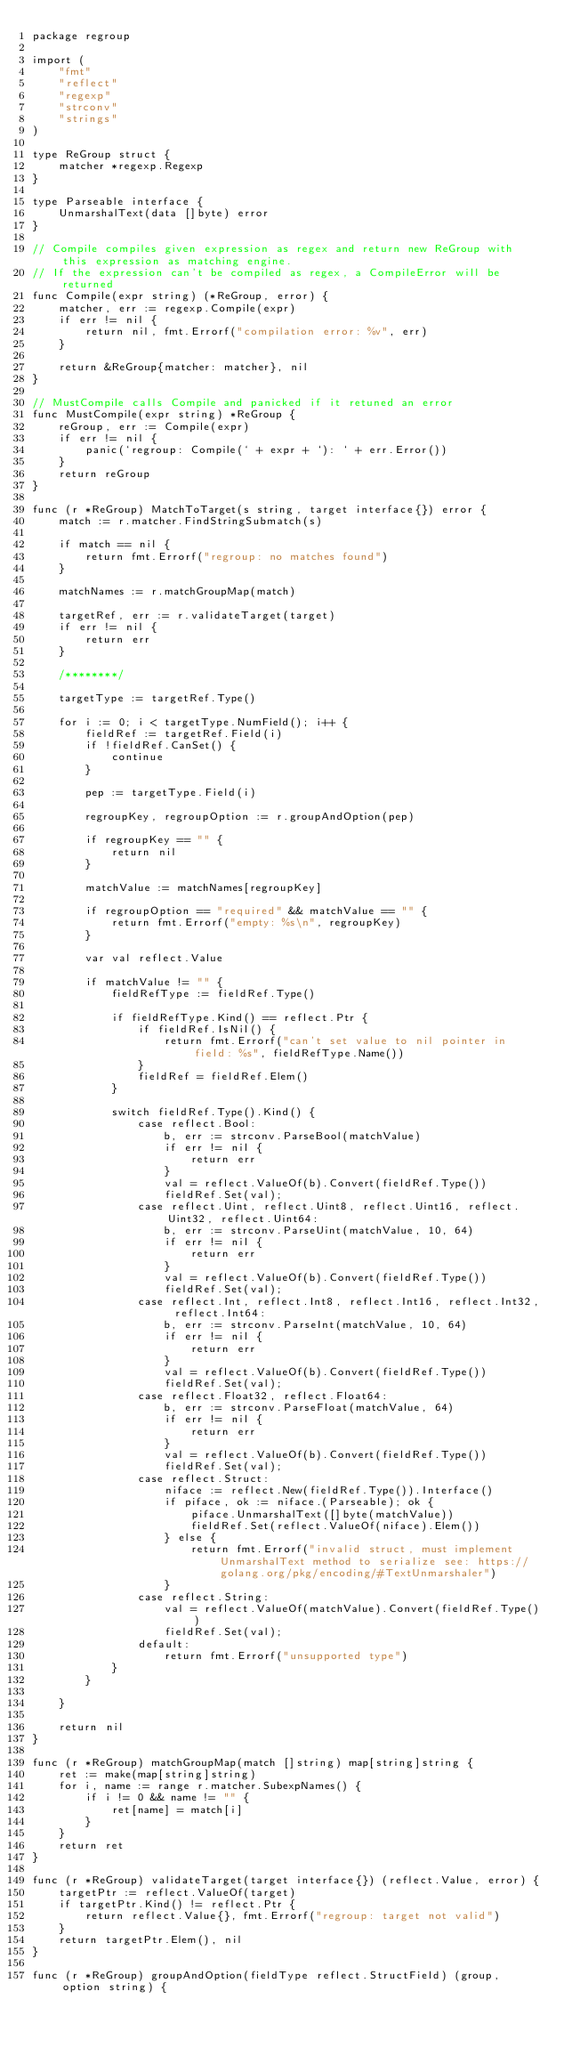<code> <loc_0><loc_0><loc_500><loc_500><_Go_>package regroup

import (
	"fmt"
	"reflect"
	"regexp"
	"strconv"
	"strings"
)

type ReGroup struct {
	matcher *regexp.Regexp
}

type Parseable interface {
	UnmarshalText(data []byte) error 
}

// Compile compiles given expression as regex and return new ReGroup with this expression as matching engine.
// If the expression can't be compiled as regex, a CompileError will be returned
func Compile(expr string) (*ReGroup, error) {
	matcher, err := regexp.Compile(expr)
	if err != nil {
		return nil, fmt.Errorf("compilation error: %v", err)
	}

	return &ReGroup{matcher: matcher}, nil
}

// MustCompile calls Compile and panicked if it retuned an error
func MustCompile(expr string) *ReGroup {
	reGroup, err := Compile(expr)
	if err != nil {
		panic(`regroup: Compile(` + expr + `): ` + err.Error())
	}
	return reGroup
}

func (r *ReGroup) MatchToTarget(s string, target interface{}) error {
	match := r.matcher.FindStringSubmatch(s)
	
	if match == nil {
		return fmt.Errorf("regroup: no matches found")
	}

	matchNames := r.matchGroupMap(match)

	targetRef, err := r.validateTarget(target)
	if err != nil {
		return err
	}

	/********/

	targetType := targetRef.Type()

	for i := 0; i < targetType.NumField(); i++ {
		fieldRef := targetRef.Field(i)
		if !fieldRef.CanSet() {
			continue
		}

		pep := targetType.Field(i)
		
		regroupKey, regroupOption := r.groupAndOption(pep)
		
		if regroupKey == "" {
			return nil
		}

		matchValue := matchNames[regroupKey]
		
		if regroupOption == "required" && matchValue == "" {
			return fmt.Errorf("empty: %s\n", regroupKey)
		}

		var val reflect.Value

		if matchValue != "" {
			fieldRefType := fieldRef.Type()

			if fieldRefType.Kind() == reflect.Ptr {
				if fieldRef.IsNil() {
					return fmt.Errorf("can't set value to nil pointer in field: %s", fieldRefType.Name())
				}
				fieldRef = fieldRef.Elem()
			}
			
			switch fieldRef.Type().Kind() {
				case reflect.Bool:
					b, err := strconv.ParseBool(matchValue)
					if err != nil {
						return err
					}
					val = reflect.ValueOf(b).Convert(fieldRef.Type())
					fieldRef.Set(val);
				case reflect.Uint, reflect.Uint8, reflect.Uint16, reflect.Uint32, reflect.Uint64:
					b, err := strconv.ParseUint(matchValue, 10, 64)
					if err != nil {
						return err
					}
					val = reflect.ValueOf(b).Convert(fieldRef.Type())
					fieldRef.Set(val);
				case reflect.Int, reflect.Int8, reflect.Int16, reflect.Int32, reflect.Int64:
					b, err := strconv.ParseInt(matchValue, 10, 64)
					if err != nil {
						return err
					}
					val = reflect.ValueOf(b).Convert(fieldRef.Type())
					fieldRef.Set(val);
				case reflect.Float32, reflect.Float64:
					b, err := strconv.ParseFloat(matchValue, 64)
					if err != nil {
						return err
					}
					val = reflect.ValueOf(b).Convert(fieldRef.Type())
					fieldRef.Set(val);
				case reflect.Struct:
					niface := reflect.New(fieldRef.Type()).Interface()
					if piface, ok := niface.(Parseable); ok {
						piface.UnmarshalText([]byte(matchValue))
						fieldRef.Set(reflect.ValueOf(niface).Elem())
					} else {
						return fmt.Errorf("invalid struct, must implement UnmarshalText method to serialize see: https://golang.org/pkg/encoding/#TextUnmarshaler")
					}
				case reflect.String:
					val = reflect.ValueOf(matchValue).Convert(fieldRef.Type())
					fieldRef.Set(val);
				default:
					return fmt.Errorf("unsupported type")
			}
		}

	}

	return nil
}

func (r *ReGroup) matchGroupMap(match []string) map[string]string {
	ret := make(map[string]string)
	for i, name := range r.matcher.SubexpNames() {
		if i != 0 && name != "" {
			ret[name] = match[i]
		}
	}
	return ret
}

func (r *ReGroup) validateTarget(target interface{}) (reflect.Value, error) {
	targetPtr := reflect.ValueOf(target)
	if targetPtr.Kind() != reflect.Ptr {
		return reflect.Value{}, fmt.Errorf("regroup: target not valid")
	}
	return targetPtr.Elem(), nil
}

func (r *ReGroup) groupAndOption(fieldType reflect.StructField) (group, option string) {</code> 